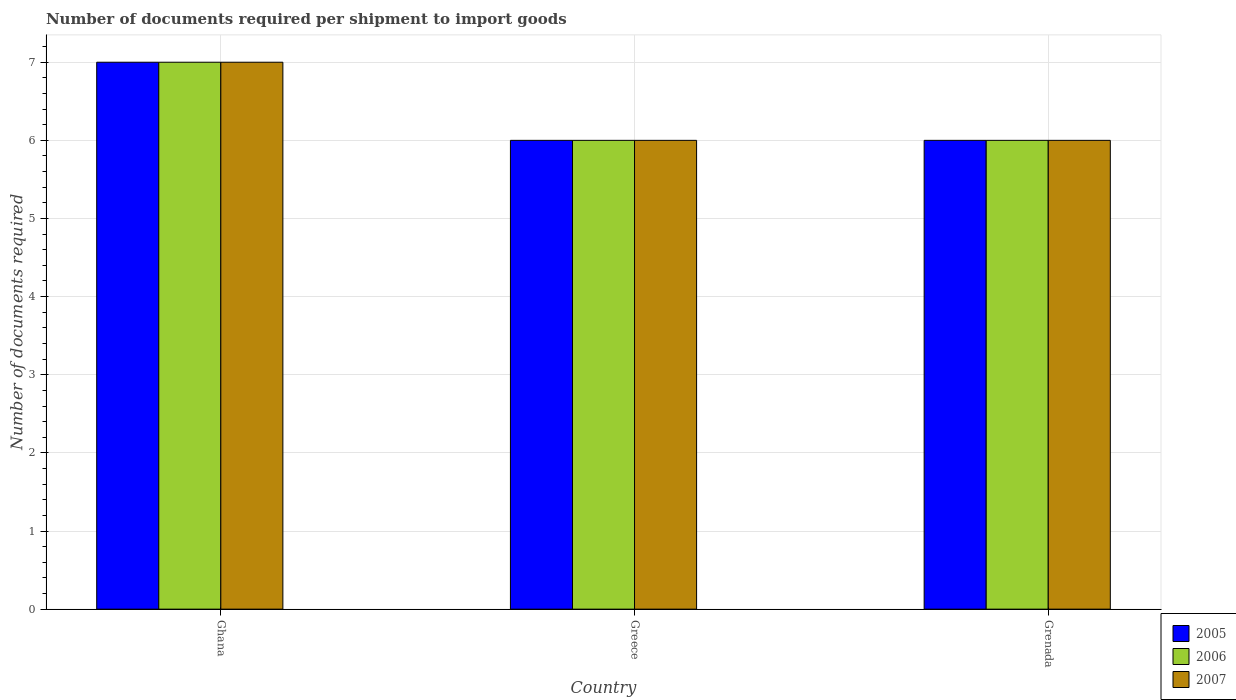How many groups of bars are there?
Provide a short and direct response. 3. Are the number of bars per tick equal to the number of legend labels?
Offer a terse response. Yes. How many bars are there on the 2nd tick from the right?
Make the answer very short. 3. What is the label of the 2nd group of bars from the left?
Offer a terse response. Greece. What is the number of documents required per shipment to import goods in 2005 in Ghana?
Your answer should be compact. 7. Across all countries, what is the minimum number of documents required per shipment to import goods in 2007?
Provide a succinct answer. 6. What is the total number of documents required per shipment to import goods in 2006 in the graph?
Keep it short and to the point. 19. What is the difference between the number of documents required per shipment to import goods in 2007 in Ghana and that in Greece?
Provide a succinct answer. 1. What is the difference between the number of documents required per shipment to import goods in 2006 in Greece and the number of documents required per shipment to import goods in 2005 in Grenada?
Ensure brevity in your answer.  0. What is the average number of documents required per shipment to import goods in 2006 per country?
Offer a terse response. 6.33. What is the ratio of the number of documents required per shipment to import goods in 2006 in Ghana to that in Grenada?
Ensure brevity in your answer.  1.17. Is the number of documents required per shipment to import goods in 2007 in Greece less than that in Grenada?
Provide a short and direct response. No. What is the difference between the highest and the second highest number of documents required per shipment to import goods in 2007?
Provide a succinct answer. -1. What is the difference between the highest and the lowest number of documents required per shipment to import goods in 2006?
Keep it short and to the point. 1. In how many countries, is the number of documents required per shipment to import goods in 2006 greater than the average number of documents required per shipment to import goods in 2006 taken over all countries?
Provide a succinct answer. 1. Is the sum of the number of documents required per shipment to import goods in 2007 in Greece and Grenada greater than the maximum number of documents required per shipment to import goods in 2006 across all countries?
Your answer should be compact. Yes. What does the 1st bar from the right in Greece represents?
Provide a succinct answer. 2007. Is it the case that in every country, the sum of the number of documents required per shipment to import goods in 2006 and number of documents required per shipment to import goods in 2007 is greater than the number of documents required per shipment to import goods in 2005?
Your answer should be compact. Yes. How many countries are there in the graph?
Offer a terse response. 3. Are the values on the major ticks of Y-axis written in scientific E-notation?
Ensure brevity in your answer.  No. Does the graph contain any zero values?
Ensure brevity in your answer.  No. Does the graph contain grids?
Offer a very short reply. Yes. Where does the legend appear in the graph?
Your response must be concise. Bottom right. How many legend labels are there?
Keep it short and to the point. 3. What is the title of the graph?
Give a very brief answer. Number of documents required per shipment to import goods. Does "1987" appear as one of the legend labels in the graph?
Your response must be concise. No. What is the label or title of the X-axis?
Your answer should be very brief. Country. What is the label or title of the Y-axis?
Ensure brevity in your answer.  Number of documents required. What is the Number of documents required in 2005 in Ghana?
Offer a terse response. 7. What is the Number of documents required of 2007 in Greece?
Keep it short and to the point. 6. What is the Number of documents required in 2005 in Grenada?
Your answer should be very brief. 6. What is the Number of documents required in 2006 in Grenada?
Provide a succinct answer. 6. What is the Number of documents required in 2007 in Grenada?
Your answer should be compact. 6. Across all countries, what is the maximum Number of documents required of 2005?
Your answer should be compact. 7. Across all countries, what is the maximum Number of documents required of 2006?
Provide a short and direct response. 7. Across all countries, what is the minimum Number of documents required in 2005?
Ensure brevity in your answer.  6. Across all countries, what is the minimum Number of documents required of 2007?
Your answer should be compact. 6. What is the total Number of documents required of 2005 in the graph?
Provide a succinct answer. 19. What is the total Number of documents required in 2006 in the graph?
Provide a short and direct response. 19. What is the difference between the Number of documents required in 2005 in Ghana and that in Greece?
Your answer should be very brief. 1. What is the difference between the Number of documents required of 2006 in Ghana and that in Greece?
Keep it short and to the point. 1. What is the difference between the Number of documents required in 2007 in Greece and that in Grenada?
Provide a short and direct response. 0. What is the difference between the Number of documents required in 2005 in Ghana and the Number of documents required in 2006 in Greece?
Offer a terse response. 1. What is the difference between the Number of documents required of 2005 in Ghana and the Number of documents required of 2007 in Greece?
Provide a short and direct response. 1. What is the difference between the Number of documents required of 2006 in Ghana and the Number of documents required of 2007 in Greece?
Offer a very short reply. 1. What is the difference between the Number of documents required of 2005 in Greece and the Number of documents required of 2006 in Grenada?
Ensure brevity in your answer.  0. What is the difference between the Number of documents required of 2005 in Greece and the Number of documents required of 2007 in Grenada?
Offer a terse response. 0. What is the average Number of documents required of 2005 per country?
Ensure brevity in your answer.  6.33. What is the average Number of documents required in 2006 per country?
Give a very brief answer. 6.33. What is the average Number of documents required of 2007 per country?
Provide a succinct answer. 6.33. What is the difference between the Number of documents required of 2005 and Number of documents required of 2006 in Ghana?
Keep it short and to the point. 0. What is the difference between the Number of documents required of 2006 and Number of documents required of 2007 in Ghana?
Your response must be concise. 0. What is the difference between the Number of documents required in 2005 and Number of documents required in 2006 in Greece?
Ensure brevity in your answer.  0. What is the difference between the Number of documents required in 2005 and Number of documents required in 2006 in Grenada?
Offer a terse response. 0. What is the ratio of the Number of documents required of 2006 in Ghana to that in Greece?
Give a very brief answer. 1.17. What is the ratio of the Number of documents required of 2006 in Ghana to that in Grenada?
Your answer should be very brief. 1.17. What is the ratio of the Number of documents required of 2006 in Greece to that in Grenada?
Provide a succinct answer. 1. What is the difference between the highest and the lowest Number of documents required of 2005?
Keep it short and to the point. 1. What is the difference between the highest and the lowest Number of documents required of 2006?
Offer a terse response. 1. What is the difference between the highest and the lowest Number of documents required in 2007?
Ensure brevity in your answer.  1. 